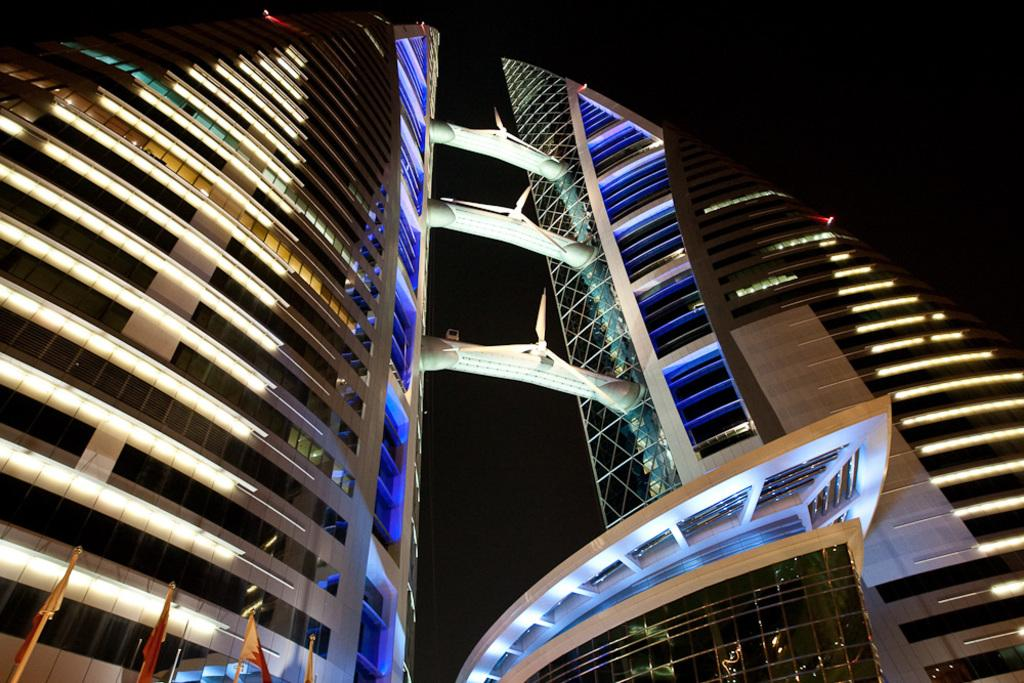What type of structures are present in the image? There are buildings in the image. What specific features can be observed on the buildings? The buildings have windows. Are there any additional elements present in the image? Yes, there are flags in the image. What can be said about the overall appearance of the image? The background of the image is dark. How many dolls can be seen playing in the quicksand in the image? There are no dolls or quicksand present in the image; it features buildings with windows and flags. 